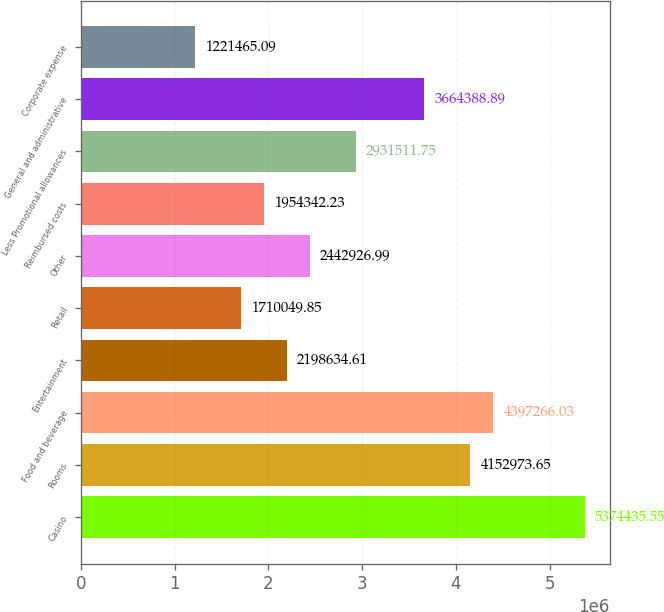Convert chart. <chart><loc_0><loc_0><loc_500><loc_500><bar_chart><fcel>Casino<fcel>Rooms<fcel>Food and beverage<fcel>Entertainment<fcel>Retail<fcel>Other<fcel>Reimbursed costs<fcel>Less Promotional allowances<fcel>General and administrative<fcel>Corporate expense<nl><fcel>5.37444e+06<fcel>4.15297e+06<fcel>4.39727e+06<fcel>2.19863e+06<fcel>1.71005e+06<fcel>2.44293e+06<fcel>1.95434e+06<fcel>2.93151e+06<fcel>3.66439e+06<fcel>1.22147e+06<nl></chart> 